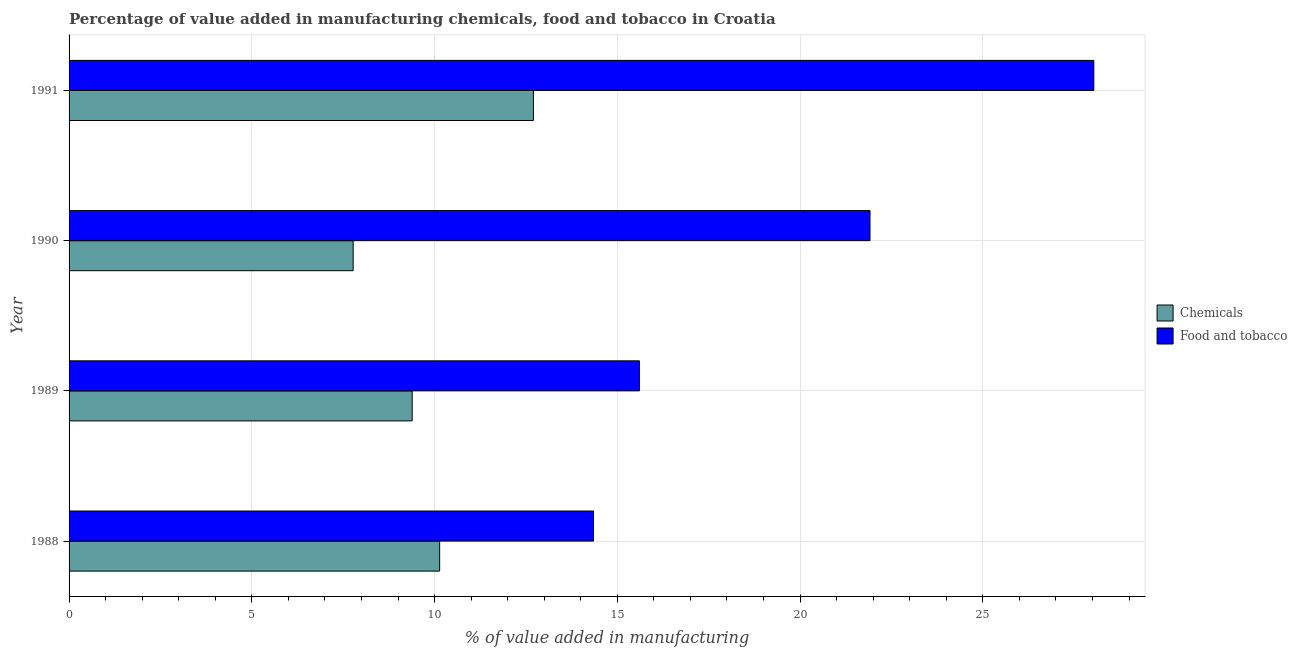Are the number of bars on each tick of the Y-axis equal?
Provide a succinct answer. Yes. How many bars are there on the 4th tick from the bottom?
Make the answer very short. 2. In how many cases, is the number of bars for a given year not equal to the number of legend labels?
Offer a very short reply. 0. What is the value added by manufacturing food and tobacco in 1989?
Your answer should be very brief. 15.6. Across all years, what is the maximum value added by manufacturing food and tobacco?
Ensure brevity in your answer.  28.04. Across all years, what is the minimum value added by manufacturing food and tobacco?
Give a very brief answer. 14.35. In which year was the value added by manufacturing food and tobacco minimum?
Your answer should be very brief. 1988. What is the total value added by  manufacturing chemicals in the graph?
Your response must be concise. 40. What is the difference between the value added by  manufacturing chemicals in 1989 and that in 1990?
Your response must be concise. 1.62. What is the difference between the value added by  manufacturing chemicals in 1990 and the value added by manufacturing food and tobacco in 1989?
Ensure brevity in your answer.  -7.83. What is the average value added by  manufacturing chemicals per year?
Offer a terse response. 10. In the year 1990, what is the difference between the value added by manufacturing food and tobacco and value added by  manufacturing chemicals?
Your answer should be very brief. 14.14. In how many years, is the value added by manufacturing food and tobacco greater than 5 %?
Offer a very short reply. 4. What is the ratio of the value added by manufacturing food and tobacco in 1988 to that in 1990?
Your answer should be compact. 0.66. Is the value added by manufacturing food and tobacco in 1988 less than that in 1989?
Offer a very short reply. Yes. Is the difference between the value added by manufacturing food and tobacco in 1989 and 1990 greater than the difference between the value added by  manufacturing chemicals in 1989 and 1990?
Make the answer very short. No. What is the difference between the highest and the second highest value added by manufacturing food and tobacco?
Offer a terse response. 6.12. What is the difference between the highest and the lowest value added by  manufacturing chemicals?
Offer a very short reply. 4.93. In how many years, is the value added by manufacturing food and tobacco greater than the average value added by manufacturing food and tobacco taken over all years?
Offer a terse response. 2. What does the 2nd bar from the top in 1991 represents?
Provide a succinct answer. Chemicals. What does the 2nd bar from the bottom in 1991 represents?
Your answer should be very brief. Food and tobacco. How many bars are there?
Offer a very short reply. 8. Are all the bars in the graph horizontal?
Offer a terse response. Yes. How many years are there in the graph?
Provide a succinct answer. 4. What is the difference between two consecutive major ticks on the X-axis?
Ensure brevity in your answer.  5. Are the values on the major ticks of X-axis written in scientific E-notation?
Offer a very short reply. No. Does the graph contain grids?
Provide a succinct answer. Yes. How many legend labels are there?
Offer a very short reply. 2. How are the legend labels stacked?
Your answer should be very brief. Vertical. What is the title of the graph?
Provide a short and direct response. Percentage of value added in manufacturing chemicals, food and tobacco in Croatia. What is the label or title of the X-axis?
Offer a very short reply. % of value added in manufacturing. What is the % of value added in manufacturing of Chemicals in 1988?
Your answer should be compact. 10.14. What is the % of value added in manufacturing in Food and tobacco in 1988?
Provide a short and direct response. 14.35. What is the % of value added in manufacturing in Chemicals in 1989?
Give a very brief answer. 9.39. What is the % of value added in manufacturing in Food and tobacco in 1989?
Your answer should be compact. 15.6. What is the % of value added in manufacturing in Chemicals in 1990?
Your response must be concise. 7.77. What is the % of value added in manufacturing in Food and tobacco in 1990?
Make the answer very short. 21.91. What is the % of value added in manufacturing in Chemicals in 1991?
Make the answer very short. 12.7. What is the % of value added in manufacturing in Food and tobacco in 1991?
Keep it short and to the point. 28.04. Across all years, what is the maximum % of value added in manufacturing of Chemicals?
Give a very brief answer. 12.7. Across all years, what is the maximum % of value added in manufacturing in Food and tobacco?
Provide a short and direct response. 28.04. Across all years, what is the minimum % of value added in manufacturing of Chemicals?
Provide a succinct answer. 7.77. Across all years, what is the minimum % of value added in manufacturing in Food and tobacco?
Ensure brevity in your answer.  14.35. What is the total % of value added in manufacturing in Chemicals in the graph?
Provide a succinct answer. 40. What is the total % of value added in manufacturing in Food and tobacco in the graph?
Give a very brief answer. 79.9. What is the difference between the % of value added in manufacturing of Chemicals in 1988 and that in 1989?
Your answer should be very brief. 0.75. What is the difference between the % of value added in manufacturing of Food and tobacco in 1988 and that in 1989?
Give a very brief answer. -1.26. What is the difference between the % of value added in manufacturing in Chemicals in 1988 and that in 1990?
Make the answer very short. 2.37. What is the difference between the % of value added in manufacturing of Food and tobacco in 1988 and that in 1990?
Provide a short and direct response. -7.57. What is the difference between the % of value added in manufacturing in Chemicals in 1988 and that in 1991?
Keep it short and to the point. -2.57. What is the difference between the % of value added in manufacturing in Food and tobacco in 1988 and that in 1991?
Make the answer very short. -13.69. What is the difference between the % of value added in manufacturing in Chemicals in 1989 and that in 1990?
Provide a succinct answer. 1.62. What is the difference between the % of value added in manufacturing of Food and tobacco in 1989 and that in 1990?
Keep it short and to the point. -6.31. What is the difference between the % of value added in manufacturing in Chemicals in 1989 and that in 1991?
Offer a very short reply. -3.32. What is the difference between the % of value added in manufacturing of Food and tobacco in 1989 and that in 1991?
Your response must be concise. -12.43. What is the difference between the % of value added in manufacturing of Chemicals in 1990 and that in 1991?
Make the answer very short. -4.93. What is the difference between the % of value added in manufacturing in Food and tobacco in 1990 and that in 1991?
Ensure brevity in your answer.  -6.12. What is the difference between the % of value added in manufacturing of Chemicals in 1988 and the % of value added in manufacturing of Food and tobacco in 1989?
Your answer should be very brief. -5.47. What is the difference between the % of value added in manufacturing in Chemicals in 1988 and the % of value added in manufacturing in Food and tobacco in 1990?
Your response must be concise. -11.77. What is the difference between the % of value added in manufacturing in Chemicals in 1988 and the % of value added in manufacturing in Food and tobacco in 1991?
Make the answer very short. -17.9. What is the difference between the % of value added in manufacturing in Chemicals in 1989 and the % of value added in manufacturing in Food and tobacco in 1990?
Give a very brief answer. -12.53. What is the difference between the % of value added in manufacturing of Chemicals in 1989 and the % of value added in manufacturing of Food and tobacco in 1991?
Provide a succinct answer. -18.65. What is the difference between the % of value added in manufacturing of Chemicals in 1990 and the % of value added in manufacturing of Food and tobacco in 1991?
Keep it short and to the point. -20.26. What is the average % of value added in manufacturing of Chemicals per year?
Offer a very short reply. 10. What is the average % of value added in manufacturing of Food and tobacco per year?
Ensure brevity in your answer.  19.98. In the year 1988, what is the difference between the % of value added in manufacturing in Chemicals and % of value added in manufacturing in Food and tobacco?
Ensure brevity in your answer.  -4.21. In the year 1989, what is the difference between the % of value added in manufacturing in Chemicals and % of value added in manufacturing in Food and tobacco?
Offer a very short reply. -6.22. In the year 1990, what is the difference between the % of value added in manufacturing in Chemicals and % of value added in manufacturing in Food and tobacco?
Offer a very short reply. -14.14. In the year 1991, what is the difference between the % of value added in manufacturing of Chemicals and % of value added in manufacturing of Food and tobacco?
Keep it short and to the point. -15.33. What is the ratio of the % of value added in manufacturing in Chemicals in 1988 to that in 1989?
Provide a succinct answer. 1.08. What is the ratio of the % of value added in manufacturing in Food and tobacco in 1988 to that in 1989?
Your answer should be compact. 0.92. What is the ratio of the % of value added in manufacturing in Chemicals in 1988 to that in 1990?
Provide a short and direct response. 1.3. What is the ratio of the % of value added in manufacturing in Food and tobacco in 1988 to that in 1990?
Provide a succinct answer. 0.65. What is the ratio of the % of value added in manufacturing in Chemicals in 1988 to that in 1991?
Offer a very short reply. 0.8. What is the ratio of the % of value added in manufacturing in Food and tobacco in 1988 to that in 1991?
Keep it short and to the point. 0.51. What is the ratio of the % of value added in manufacturing of Chemicals in 1989 to that in 1990?
Offer a terse response. 1.21. What is the ratio of the % of value added in manufacturing in Food and tobacco in 1989 to that in 1990?
Your response must be concise. 0.71. What is the ratio of the % of value added in manufacturing of Chemicals in 1989 to that in 1991?
Make the answer very short. 0.74. What is the ratio of the % of value added in manufacturing in Food and tobacco in 1989 to that in 1991?
Ensure brevity in your answer.  0.56. What is the ratio of the % of value added in manufacturing of Chemicals in 1990 to that in 1991?
Give a very brief answer. 0.61. What is the ratio of the % of value added in manufacturing in Food and tobacco in 1990 to that in 1991?
Offer a very short reply. 0.78. What is the difference between the highest and the second highest % of value added in manufacturing in Chemicals?
Offer a very short reply. 2.57. What is the difference between the highest and the second highest % of value added in manufacturing in Food and tobacco?
Offer a terse response. 6.12. What is the difference between the highest and the lowest % of value added in manufacturing of Chemicals?
Provide a succinct answer. 4.93. What is the difference between the highest and the lowest % of value added in manufacturing in Food and tobacco?
Provide a short and direct response. 13.69. 